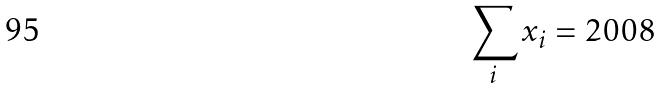<formula> <loc_0><loc_0><loc_500><loc_500>\sum _ { i } x _ { i } = 2 0 0 8</formula> 